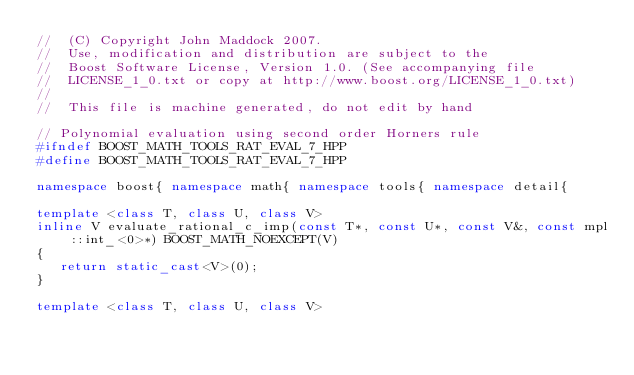Convert code to text. <code><loc_0><loc_0><loc_500><loc_500><_C++_>//  (C) Copyright John Maddock 2007.
//  Use, modification and distribution are subject to the
//  Boost Software License, Version 1.0. (See accompanying file
//  LICENSE_1_0.txt or copy at http://www.boost.org/LICENSE_1_0.txt)
//
//  This file is machine generated, do not edit by hand

// Polynomial evaluation using second order Horners rule
#ifndef BOOST_MATH_TOOLS_RAT_EVAL_7_HPP
#define BOOST_MATH_TOOLS_RAT_EVAL_7_HPP

namespace boost{ namespace math{ namespace tools{ namespace detail{

template <class T, class U, class V>
inline V evaluate_rational_c_imp(const T*, const U*, const V&, const mpl::int_<0>*) BOOST_MATH_NOEXCEPT(V)
{
   return static_cast<V>(0);
}

template <class T, class U, class V></code> 